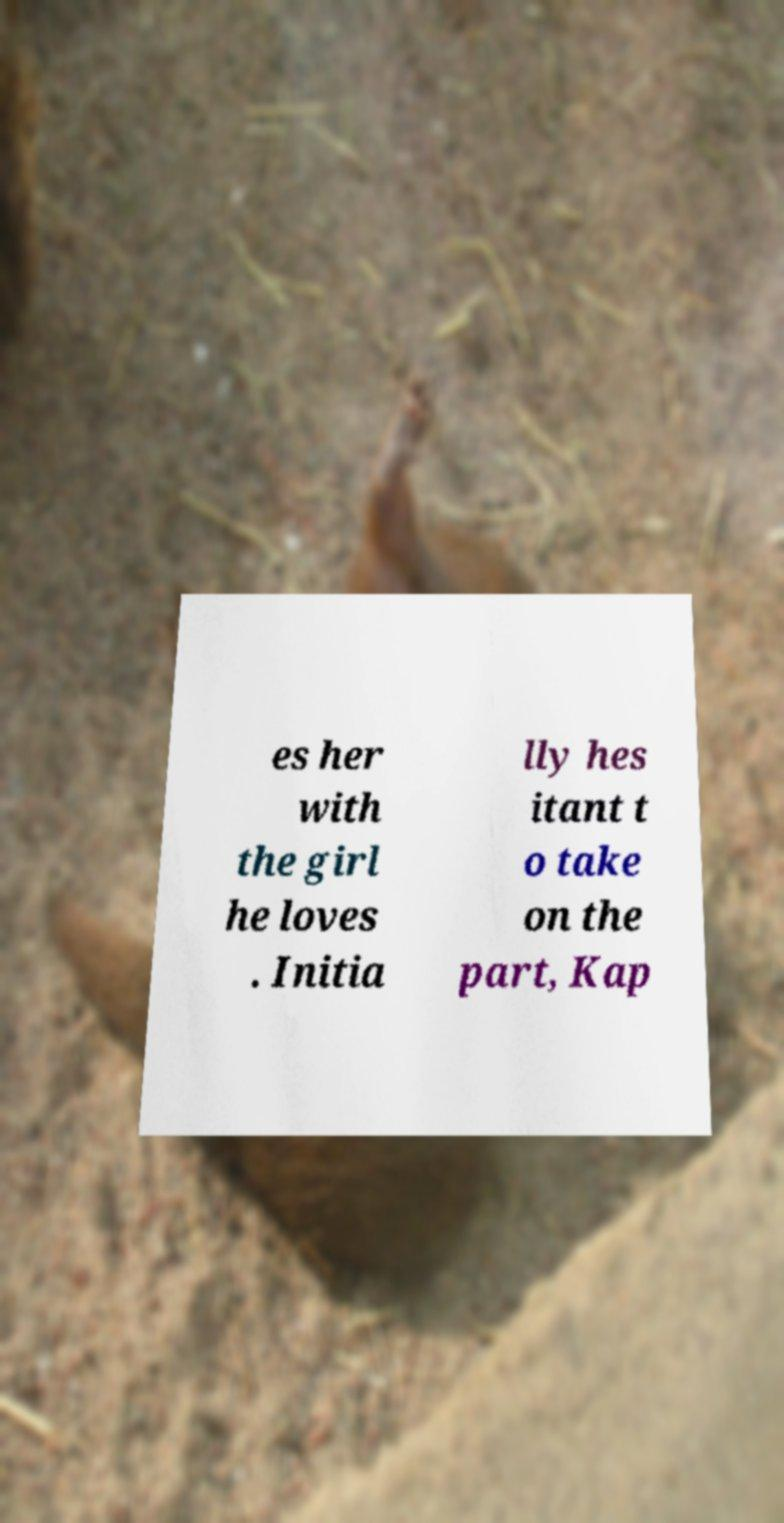Can you read and provide the text displayed in the image?This photo seems to have some interesting text. Can you extract and type it out for me? es her with the girl he loves . Initia lly hes itant t o take on the part, Kap 